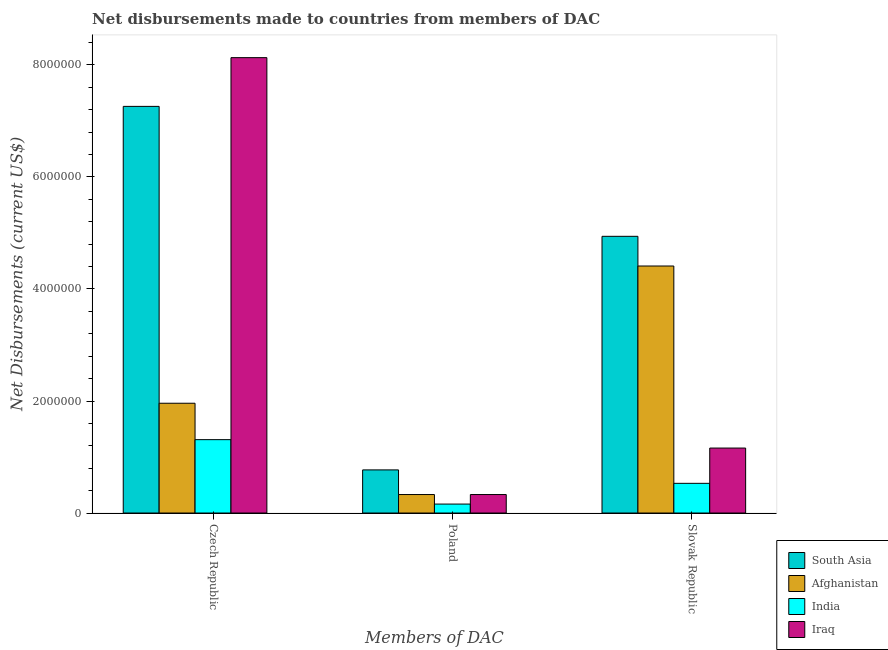How many groups of bars are there?
Provide a short and direct response. 3. How many bars are there on the 1st tick from the left?
Make the answer very short. 4. What is the label of the 2nd group of bars from the left?
Offer a very short reply. Poland. What is the net disbursements made by czech republic in South Asia?
Your response must be concise. 7.26e+06. Across all countries, what is the maximum net disbursements made by slovak republic?
Your answer should be very brief. 4.94e+06. Across all countries, what is the minimum net disbursements made by slovak republic?
Provide a short and direct response. 5.30e+05. In which country was the net disbursements made by poland minimum?
Offer a terse response. India. What is the total net disbursements made by poland in the graph?
Offer a terse response. 1.59e+06. What is the difference between the net disbursements made by poland in Iraq and that in South Asia?
Provide a succinct answer. -4.40e+05. What is the difference between the net disbursements made by poland in Iraq and the net disbursements made by czech republic in India?
Your answer should be very brief. -9.80e+05. What is the average net disbursements made by czech republic per country?
Offer a very short reply. 4.66e+06. What is the difference between the net disbursements made by slovak republic and net disbursements made by czech republic in South Asia?
Make the answer very short. -2.32e+06. What is the ratio of the net disbursements made by czech republic in India to that in South Asia?
Offer a terse response. 0.18. What is the difference between the highest and the second highest net disbursements made by slovak republic?
Make the answer very short. 5.30e+05. What is the difference between the highest and the lowest net disbursements made by poland?
Keep it short and to the point. 6.10e+05. In how many countries, is the net disbursements made by poland greater than the average net disbursements made by poland taken over all countries?
Keep it short and to the point. 1. Is the sum of the net disbursements made by czech republic in Iraq and South Asia greater than the maximum net disbursements made by slovak republic across all countries?
Keep it short and to the point. Yes. What does the 2nd bar from the right in Slovak Republic represents?
Offer a very short reply. India. How many bars are there?
Ensure brevity in your answer.  12. Are all the bars in the graph horizontal?
Provide a succinct answer. No. What is the difference between two consecutive major ticks on the Y-axis?
Give a very brief answer. 2.00e+06. Does the graph contain any zero values?
Your answer should be very brief. No. Where does the legend appear in the graph?
Your answer should be compact. Bottom right. How many legend labels are there?
Your response must be concise. 4. What is the title of the graph?
Offer a terse response. Net disbursements made to countries from members of DAC. What is the label or title of the X-axis?
Offer a terse response. Members of DAC. What is the label or title of the Y-axis?
Keep it short and to the point. Net Disbursements (current US$). What is the Net Disbursements (current US$) in South Asia in Czech Republic?
Your response must be concise. 7.26e+06. What is the Net Disbursements (current US$) in Afghanistan in Czech Republic?
Offer a terse response. 1.96e+06. What is the Net Disbursements (current US$) of India in Czech Republic?
Provide a short and direct response. 1.31e+06. What is the Net Disbursements (current US$) in Iraq in Czech Republic?
Provide a short and direct response. 8.13e+06. What is the Net Disbursements (current US$) in South Asia in Poland?
Make the answer very short. 7.70e+05. What is the Net Disbursements (current US$) of Iraq in Poland?
Ensure brevity in your answer.  3.30e+05. What is the Net Disbursements (current US$) of South Asia in Slovak Republic?
Give a very brief answer. 4.94e+06. What is the Net Disbursements (current US$) in Afghanistan in Slovak Republic?
Give a very brief answer. 4.41e+06. What is the Net Disbursements (current US$) of India in Slovak Republic?
Provide a short and direct response. 5.30e+05. What is the Net Disbursements (current US$) in Iraq in Slovak Republic?
Make the answer very short. 1.16e+06. Across all Members of DAC, what is the maximum Net Disbursements (current US$) in South Asia?
Your answer should be very brief. 7.26e+06. Across all Members of DAC, what is the maximum Net Disbursements (current US$) of Afghanistan?
Provide a short and direct response. 4.41e+06. Across all Members of DAC, what is the maximum Net Disbursements (current US$) in India?
Provide a succinct answer. 1.31e+06. Across all Members of DAC, what is the maximum Net Disbursements (current US$) of Iraq?
Your answer should be compact. 8.13e+06. Across all Members of DAC, what is the minimum Net Disbursements (current US$) of South Asia?
Offer a very short reply. 7.70e+05. Across all Members of DAC, what is the minimum Net Disbursements (current US$) in India?
Offer a terse response. 1.60e+05. Across all Members of DAC, what is the minimum Net Disbursements (current US$) of Iraq?
Provide a short and direct response. 3.30e+05. What is the total Net Disbursements (current US$) in South Asia in the graph?
Your answer should be very brief. 1.30e+07. What is the total Net Disbursements (current US$) of Afghanistan in the graph?
Offer a very short reply. 6.70e+06. What is the total Net Disbursements (current US$) of India in the graph?
Your response must be concise. 2.00e+06. What is the total Net Disbursements (current US$) of Iraq in the graph?
Ensure brevity in your answer.  9.62e+06. What is the difference between the Net Disbursements (current US$) in South Asia in Czech Republic and that in Poland?
Make the answer very short. 6.49e+06. What is the difference between the Net Disbursements (current US$) of Afghanistan in Czech Republic and that in Poland?
Give a very brief answer. 1.63e+06. What is the difference between the Net Disbursements (current US$) in India in Czech Republic and that in Poland?
Provide a succinct answer. 1.15e+06. What is the difference between the Net Disbursements (current US$) in Iraq in Czech Republic and that in Poland?
Your answer should be very brief. 7.80e+06. What is the difference between the Net Disbursements (current US$) in South Asia in Czech Republic and that in Slovak Republic?
Your answer should be very brief. 2.32e+06. What is the difference between the Net Disbursements (current US$) of Afghanistan in Czech Republic and that in Slovak Republic?
Your answer should be compact. -2.45e+06. What is the difference between the Net Disbursements (current US$) of India in Czech Republic and that in Slovak Republic?
Give a very brief answer. 7.80e+05. What is the difference between the Net Disbursements (current US$) in Iraq in Czech Republic and that in Slovak Republic?
Your response must be concise. 6.97e+06. What is the difference between the Net Disbursements (current US$) in South Asia in Poland and that in Slovak Republic?
Keep it short and to the point. -4.17e+06. What is the difference between the Net Disbursements (current US$) in Afghanistan in Poland and that in Slovak Republic?
Your answer should be very brief. -4.08e+06. What is the difference between the Net Disbursements (current US$) in India in Poland and that in Slovak Republic?
Offer a very short reply. -3.70e+05. What is the difference between the Net Disbursements (current US$) of Iraq in Poland and that in Slovak Republic?
Your answer should be very brief. -8.30e+05. What is the difference between the Net Disbursements (current US$) in South Asia in Czech Republic and the Net Disbursements (current US$) in Afghanistan in Poland?
Ensure brevity in your answer.  6.93e+06. What is the difference between the Net Disbursements (current US$) of South Asia in Czech Republic and the Net Disbursements (current US$) of India in Poland?
Make the answer very short. 7.10e+06. What is the difference between the Net Disbursements (current US$) in South Asia in Czech Republic and the Net Disbursements (current US$) in Iraq in Poland?
Offer a terse response. 6.93e+06. What is the difference between the Net Disbursements (current US$) in Afghanistan in Czech Republic and the Net Disbursements (current US$) in India in Poland?
Give a very brief answer. 1.80e+06. What is the difference between the Net Disbursements (current US$) in Afghanistan in Czech Republic and the Net Disbursements (current US$) in Iraq in Poland?
Offer a very short reply. 1.63e+06. What is the difference between the Net Disbursements (current US$) in India in Czech Republic and the Net Disbursements (current US$) in Iraq in Poland?
Ensure brevity in your answer.  9.80e+05. What is the difference between the Net Disbursements (current US$) of South Asia in Czech Republic and the Net Disbursements (current US$) of Afghanistan in Slovak Republic?
Ensure brevity in your answer.  2.85e+06. What is the difference between the Net Disbursements (current US$) of South Asia in Czech Republic and the Net Disbursements (current US$) of India in Slovak Republic?
Provide a short and direct response. 6.73e+06. What is the difference between the Net Disbursements (current US$) in South Asia in Czech Republic and the Net Disbursements (current US$) in Iraq in Slovak Republic?
Your answer should be very brief. 6.10e+06. What is the difference between the Net Disbursements (current US$) in Afghanistan in Czech Republic and the Net Disbursements (current US$) in India in Slovak Republic?
Give a very brief answer. 1.43e+06. What is the difference between the Net Disbursements (current US$) in Afghanistan in Czech Republic and the Net Disbursements (current US$) in Iraq in Slovak Republic?
Make the answer very short. 8.00e+05. What is the difference between the Net Disbursements (current US$) of India in Czech Republic and the Net Disbursements (current US$) of Iraq in Slovak Republic?
Your response must be concise. 1.50e+05. What is the difference between the Net Disbursements (current US$) of South Asia in Poland and the Net Disbursements (current US$) of Afghanistan in Slovak Republic?
Offer a terse response. -3.64e+06. What is the difference between the Net Disbursements (current US$) of South Asia in Poland and the Net Disbursements (current US$) of India in Slovak Republic?
Your answer should be compact. 2.40e+05. What is the difference between the Net Disbursements (current US$) of South Asia in Poland and the Net Disbursements (current US$) of Iraq in Slovak Republic?
Ensure brevity in your answer.  -3.90e+05. What is the difference between the Net Disbursements (current US$) of Afghanistan in Poland and the Net Disbursements (current US$) of Iraq in Slovak Republic?
Your answer should be compact. -8.30e+05. What is the average Net Disbursements (current US$) in South Asia per Members of DAC?
Keep it short and to the point. 4.32e+06. What is the average Net Disbursements (current US$) of Afghanistan per Members of DAC?
Ensure brevity in your answer.  2.23e+06. What is the average Net Disbursements (current US$) in India per Members of DAC?
Offer a very short reply. 6.67e+05. What is the average Net Disbursements (current US$) of Iraq per Members of DAC?
Provide a succinct answer. 3.21e+06. What is the difference between the Net Disbursements (current US$) in South Asia and Net Disbursements (current US$) in Afghanistan in Czech Republic?
Ensure brevity in your answer.  5.30e+06. What is the difference between the Net Disbursements (current US$) in South Asia and Net Disbursements (current US$) in India in Czech Republic?
Your answer should be compact. 5.95e+06. What is the difference between the Net Disbursements (current US$) of South Asia and Net Disbursements (current US$) of Iraq in Czech Republic?
Ensure brevity in your answer.  -8.70e+05. What is the difference between the Net Disbursements (current US$) of Afghanistan and Net Disbursements (current US$) of India in Czech Republic?
Offer a very short reply. 6.50e+05. What is the difference between the Net Disbursements (current US$) of Afghanistan and Net Disbursements (current US$) of Iraq in Czech Republic?
Provide a succinct answer. -6.17e+06. What is the difference between the Net Disbursements (current US$) of India and Net Disbursements (current US$) of Iraq in Czech Republic?
Ensure brevity in your answer.  -6.82e+06. What is the difference between the Net Disbursements (current US$) in South Asia and Net Disbursements (current US$) in India in Poland?
Make the answer very short. 6.10e+05. What is the difference between the Net Disbursements (current US$) of South Asia and Net Disbursements (current US$) of Iraq in Poland?
Your response must be concise. 4.40e+05. What is the difference between the Net Disbursements (current US$) of Afghanistan and Net Disbursements (current US$) of India in Poland?
Offer a very short reply. 1.70e+05. What is the difference between the Net Disbursements (current US$) of South Asia and Net Disbursements (current US$) of Afghanistan in Slovak Republic?
Provide a short and direct response. 5.30e+05. What is the difference between the Net Disbursements (current US$) of South Asia and Net Disbursements (current US$) of India in Slovak Republic?
Your answer should be compact. 4.41e+06. What is the difference between the Net Disbursements (current US$) in South Asia and Net Disbursements (current US$) in Iraq in Slovak Republic?
Your answer should be very brief. 3.78e+06. What is the difference between the Net Disbursements (current US$) of Afghanistan and Net Disbursements (current US$) of India in Slovak Republic?
Your response must be concise. 3.88e+06. What is the difference between the Net Disbursements (current US$) of Afghanistan and Net Disbursements (current US$) of Iraq in Slovak Republic?
Ensure brevity in your answer.  3.25e+06. What is the difference between the Net Disbursements (current US$) in India and Net Disbursements (current US$) in Iraq in Slovak Republic?
Give a very brief answer. -6.30e+05. What is the ratio of the Net Disbursements (current US$) of South Asia in Czech Republic to that in Poland?
Your response must be concise. 9.43. What is the ratio of the Net Disbursements (current US$) of Afghanistan in Czech Republic to that in Poland?
Give a very brief answer. 5.94. What is the ratio of the Net Disbursements (current US$) of India in Czech Republic to that in Poland?
Your answer should be very brief. 8.19. What is the ratio of the Net Disbursements (current US$) of Iraq in Czech Republic to that in Poland?
Make the answer very short. 24.64. What is the ratio of the Net Disbursements (current US$) in South Asia in Czech Republic to that in Slovak Republic?
Keep it short and to the point. 1.47. What is the ratio of the Net Disbursements (current US$) in Afghanistan in Czech Republic to that in Slovak Republic?
Make the answer very short. 0.44. What is the ratio of the Net Disbursements (current US$) of India in Czech Republic to that in Slovak Republic?
Make the answer very short. 2.47. What is the ratio of the Net Disbursements (current US$) of Iraq in Czech Republic to that in Slovak Republic?
Make the answer very short. 7.01. What is the ratio of the Net Disbursements (current US$) of South Asia in Poland to that in Slovak Republic?
Your answer should be compact. 0.16. What is the ratio of the Net Disbursements (current US$) in Afghanistan in Poland to that in Slovak Republic?
Make the answer very short. 0.07. What is the ratio of the Net Disbursements (current US$) of India in Poland to that in Slovak Republic?
Ensure brevity in your answer.  0.3. What is the ratio of the Net Disbursements (current US$) of Iraq in Poland to that in Slovak Republic?
Your answer should be compact. 0.28. What is the difference between the highest and the second highest Net Disbursements (current US$) of South Asia?
Offer a terse response. 2.32e+06. What is the difference between the highest and the second highest Net Disbursements (current US$) in Afghanistan?
Provide a succinct answer. 2.45e+06. What is the difference between the highest and the second highest Net Disbursements (current US$) in India?
Your response must be concise. 7.80e+05. What is the difference between the highest and the second highest Net Disbursements (current US$) of Iraq?
Ensure brevity in your answer.  6.97e+06. What is the difference between the highest and the lowest Net Disbursements (current US$) in South Asia?
Give a very brief answer. 6.49e+06. What is the difference between the highest and the lowest Net Disbursements (current US$) of Afghanistan?
Keep it short and to the point. 4.08e+06. What is the difference between the highest and the lowest Net Disbursements (current US$) in India?
Provide a short and direct response. 1.15e+06. What is the difference between the highest and the lowest Net Disbursements (current US$) of Iraq?
Offer a very short reply. 7.80e+06. 